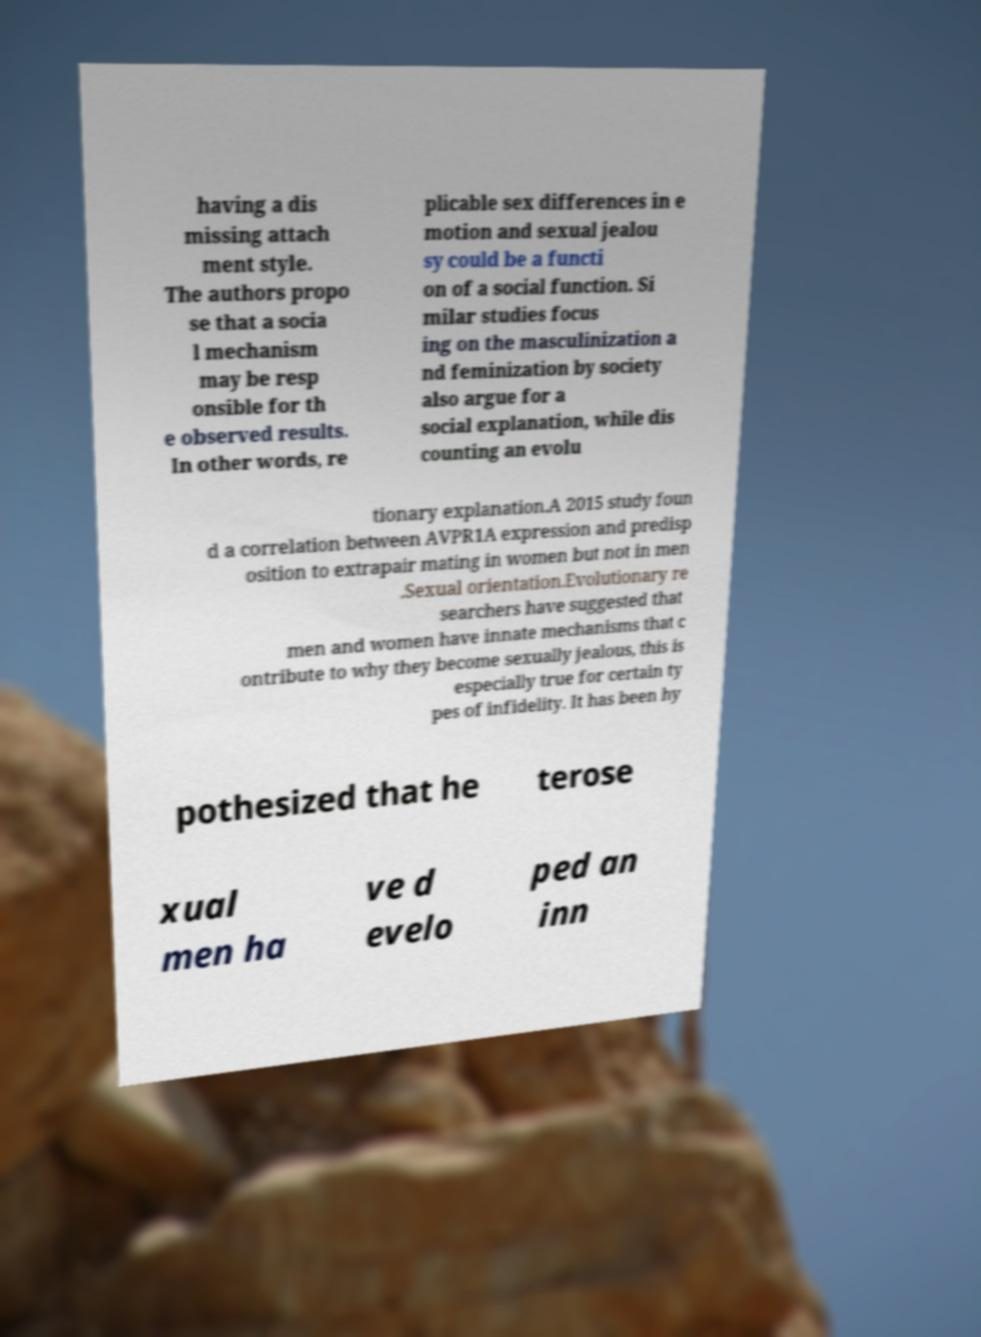What messages or text are displayed in this image? I need them in a readable, typed format. having a dis missing attach ment style. The authors propo se that a socia l mechanism may be resp onsible for th e observed results. In other words, re plicable sex differences in e motion and sexual jealou sy could be a functi on of a social function. Si milar studies focus ing on the masculinization a nd feminization by society also argue for a social explanation, while dis counting an evolu tionary explanation.A 2015 study foun d a correlation between AVPR1A expression and predisp osition to extrapair mating in women but not in men .Sexual orientation.Evolutionary re searchers have suggested that men and women have innate mechanisms that c ontribute to why they become sexually jealous, this is especially true for certain ty pes of infidelity. It has been hy pothesized that he terose xual men ha ve d evelo ped an inn 